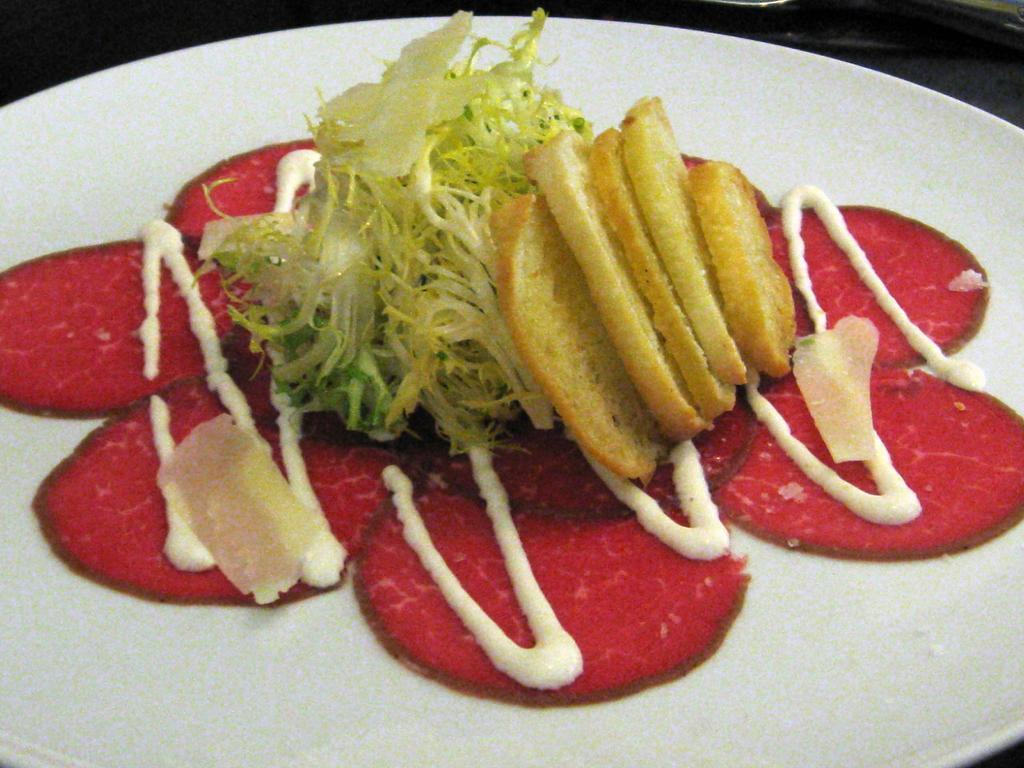Please provide a concise description of this image. In this image there is a food item placed on a plate. 